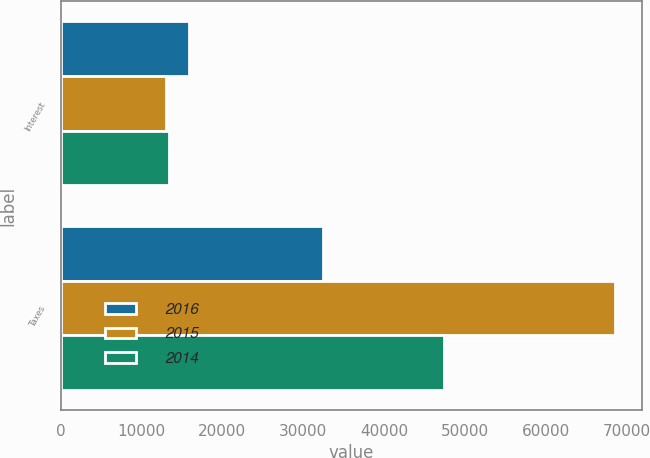<chart> <loc_0><loc_0><loc_500><loc_500><stacked_bar_chart><ecel><fcel>Interest<fcel>Taxes<nl><fcel>2016<fcel>15815<fcel>32465<nl><fcel>2015<fcel>13039<fcel>68534<nl><fcel>2014<fcel>13410<fcel>47434<nl></chart> 